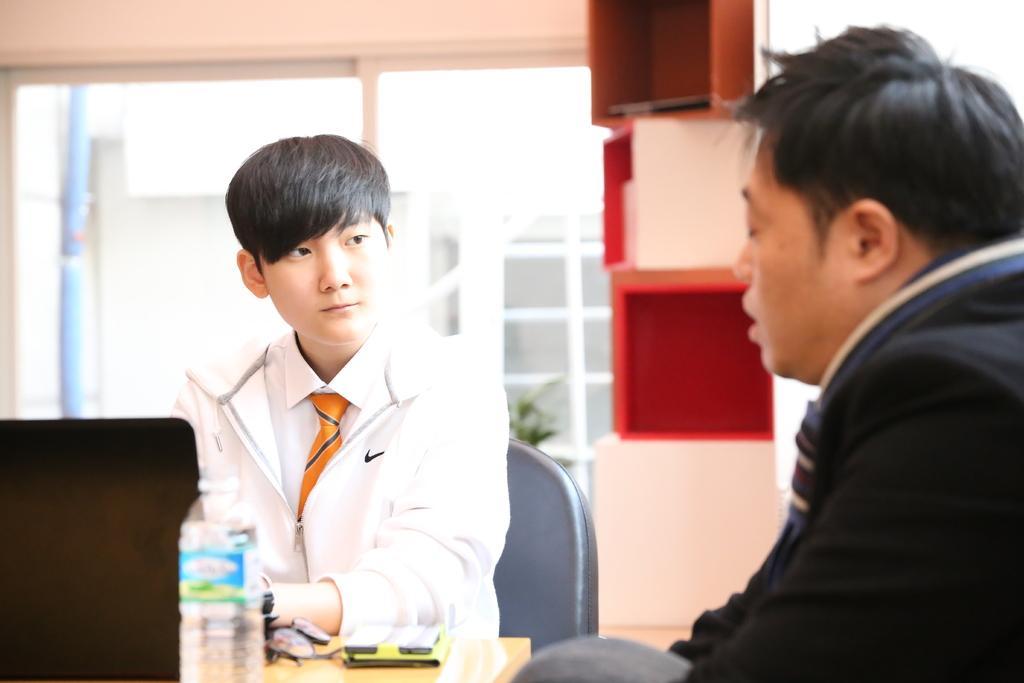Can you describe this image briefly? In this picture we can see two men wore blazer, tie sitting on chairs and in front of them on table we have see bottle, spectacle, device and in background we can see window, cupboards. 